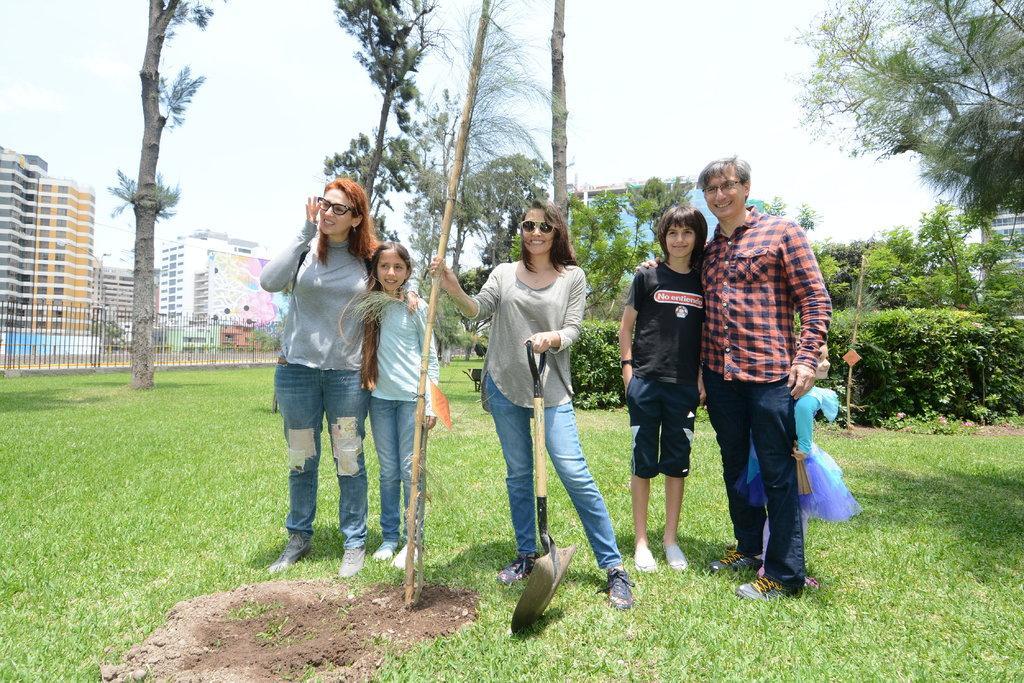In one or two sentences, can you explain what this image depicts? On the right there is a man who is wearing shirt, jeans and shoe. Back side of him we can see a girl. Beside him we can see a boy who is wearing black dress. In the center there is a woman who is holding this bamboo. Here we can see a girl who is standing beside a woman. On the bottom we can see grass. On the background we can see buildings, fencing, plants and trees. On the top there is a sky. 